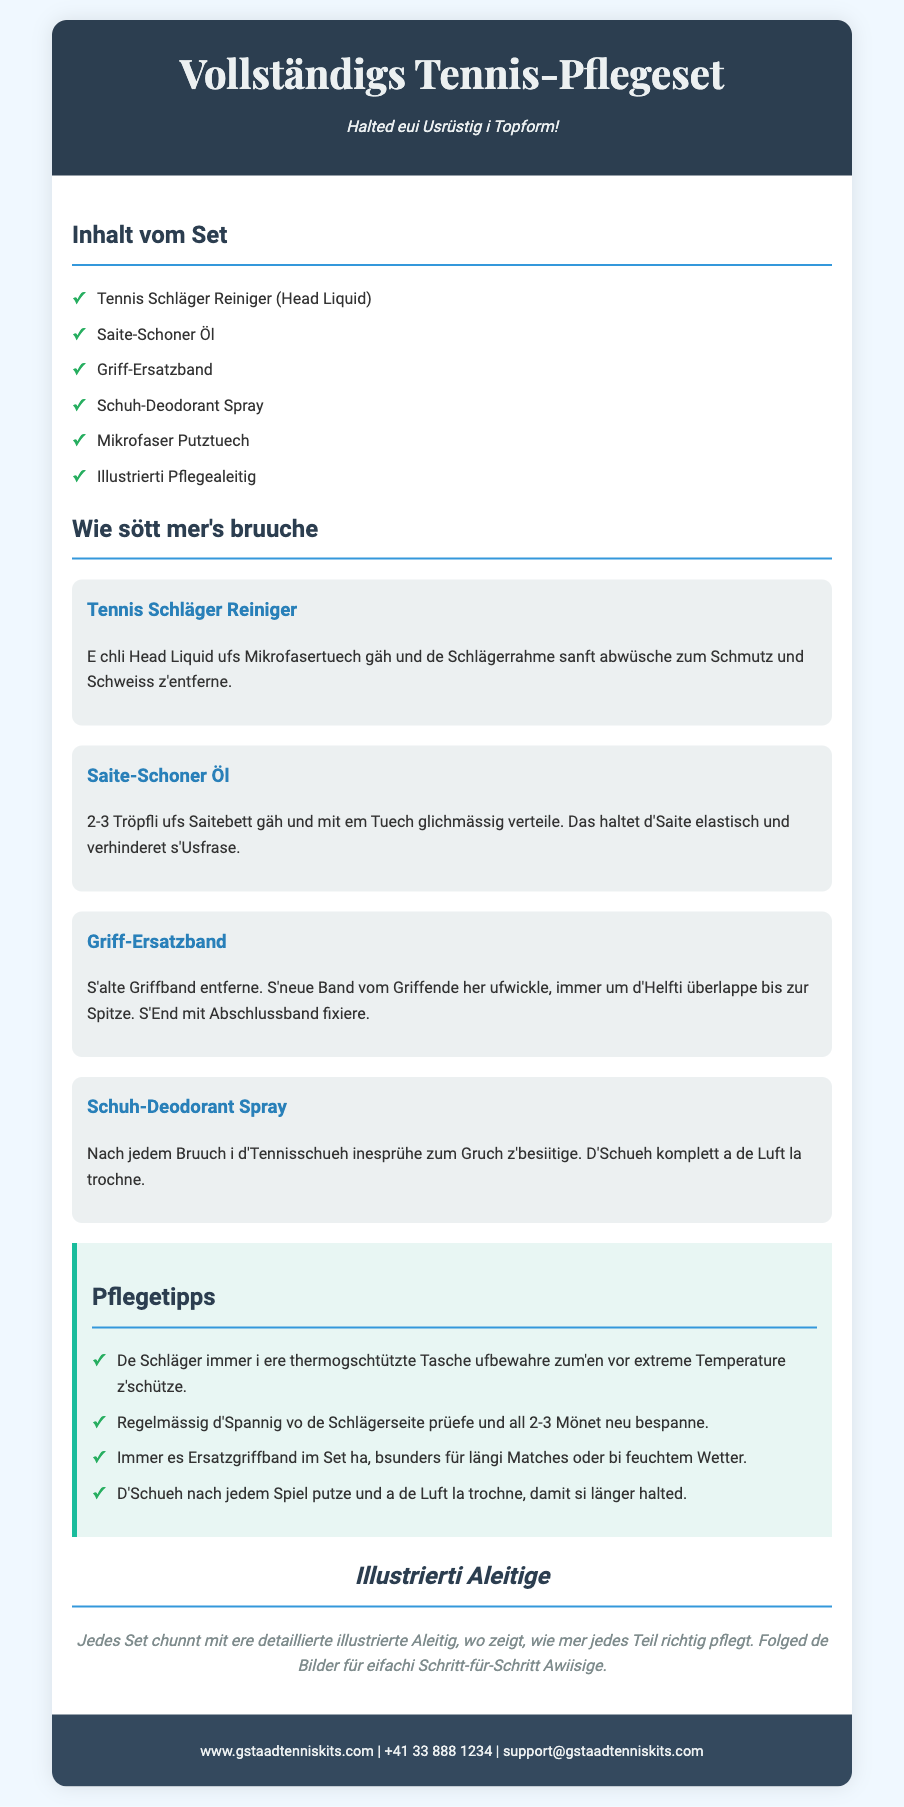Was isch im Set enthalte? Die Inhaltsliste im Dokument zeigt alle Teile, die im Tennis-Pflegeset enthalten sind.
Answer: Tennis Schläger Reiniger, Saite-Schoner Öl, Griff-Ersatzband, Schuh-Deodorant Spray, Mikrofaser Putztuech, Illustrierti Pflegealeitig Wie sött mer den Schläger reinigen? Der Abschnitt über die Anwendung beschreibt, wie man den Schläger mit dem Reiniger behandelt.
Answer: E chli Head Liquid ufs Mikrofasertuech gäh und de Schlägerrahme sanft abwüsche Was isch d’Funktion vom Saite-Schoner Öl? In der Anwendung wird erklärt, dass das Öl die Saite elastisch hält.
Answer: Haltet d'Saite elastisch und verhinderet s'Usfrase Wie vill Tröpfli mues mer uf d'Saite gäh? Die Gebrauchsanweisung spezifiziert die Anzahl der Tröpfli für die Anwendung.
Answer: 2-3 Tröpfli Was mues mer nach jedem Bruuch mit de Schueh mache? Dieser Punkt in der Anleitung gibt wichtige Pflegetipps für Schuhe nach dem Spiel.
Answer: I d'Tennisschueh inesprühe zum Gruch z'besiitige Wos für Tipps gibt es zum Schläger-Pflege? Die Pflegetipps geben praktische Hinweise zum Schutz des Schlägers.
Answer: De Schläger immer i ere thermogschtützte Tasche ufbewahre Was isch d’Ziel vo de illustrierte Aleitige? Der Abschnitt erklärt den Zweck und die Nützlichkeit der beiliegenden Anleitung.
Answer: Zeigt, wie mer jedes Teil richtig pflegt Wie oft sött mer d'Spannig vo de Schlägerseite prüefe? Die Pflegetipps geben eine zeitliche Empfehlung für die Überprüfung der Spannung an.
Answer: All 2-3 Mönet 